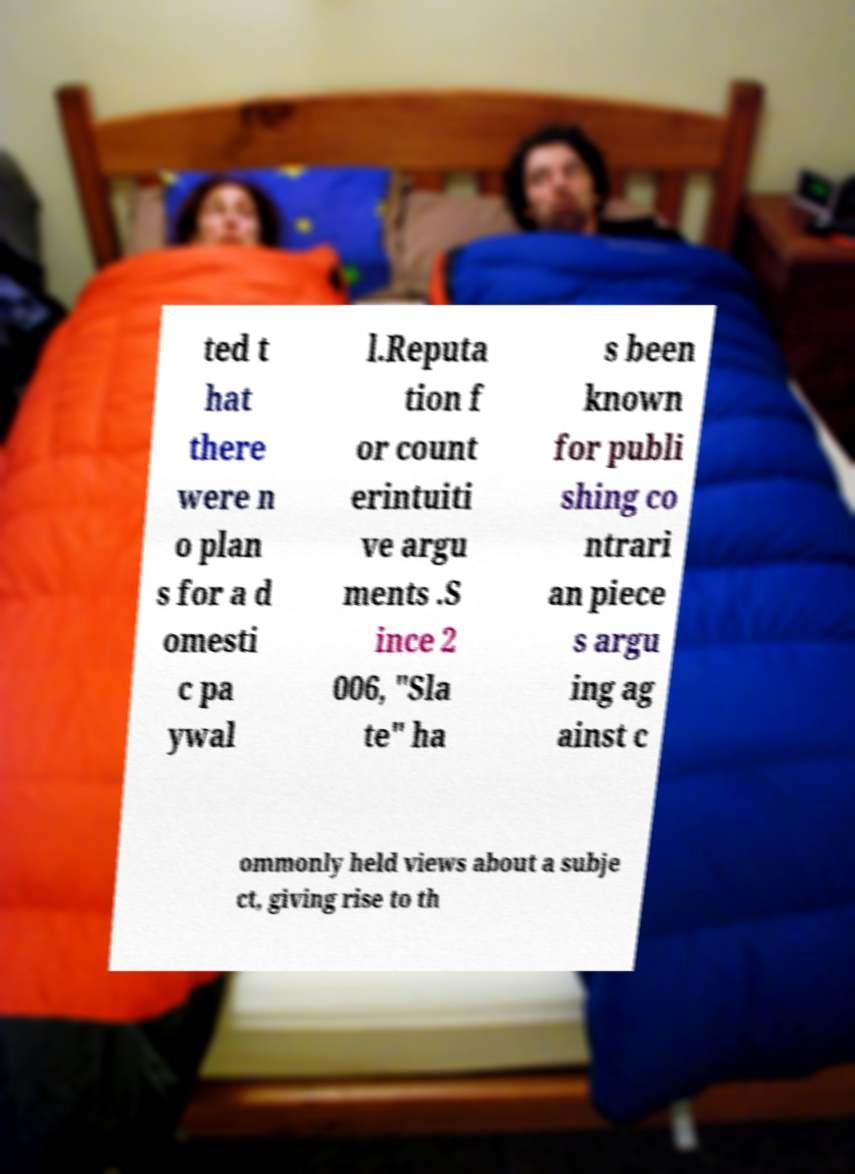Please identify and transcribe the text found in this image. ted t hat there were n o plan s for a d omesti c pa ywal l.Reputa tion f or count erintuiti ve argu ments .S ince 2 006, "Sla te" ha s been known for publi shing co ntrari an piece s argu ing ag ainst c ommonly held views about a subje ct, giving rise to th 